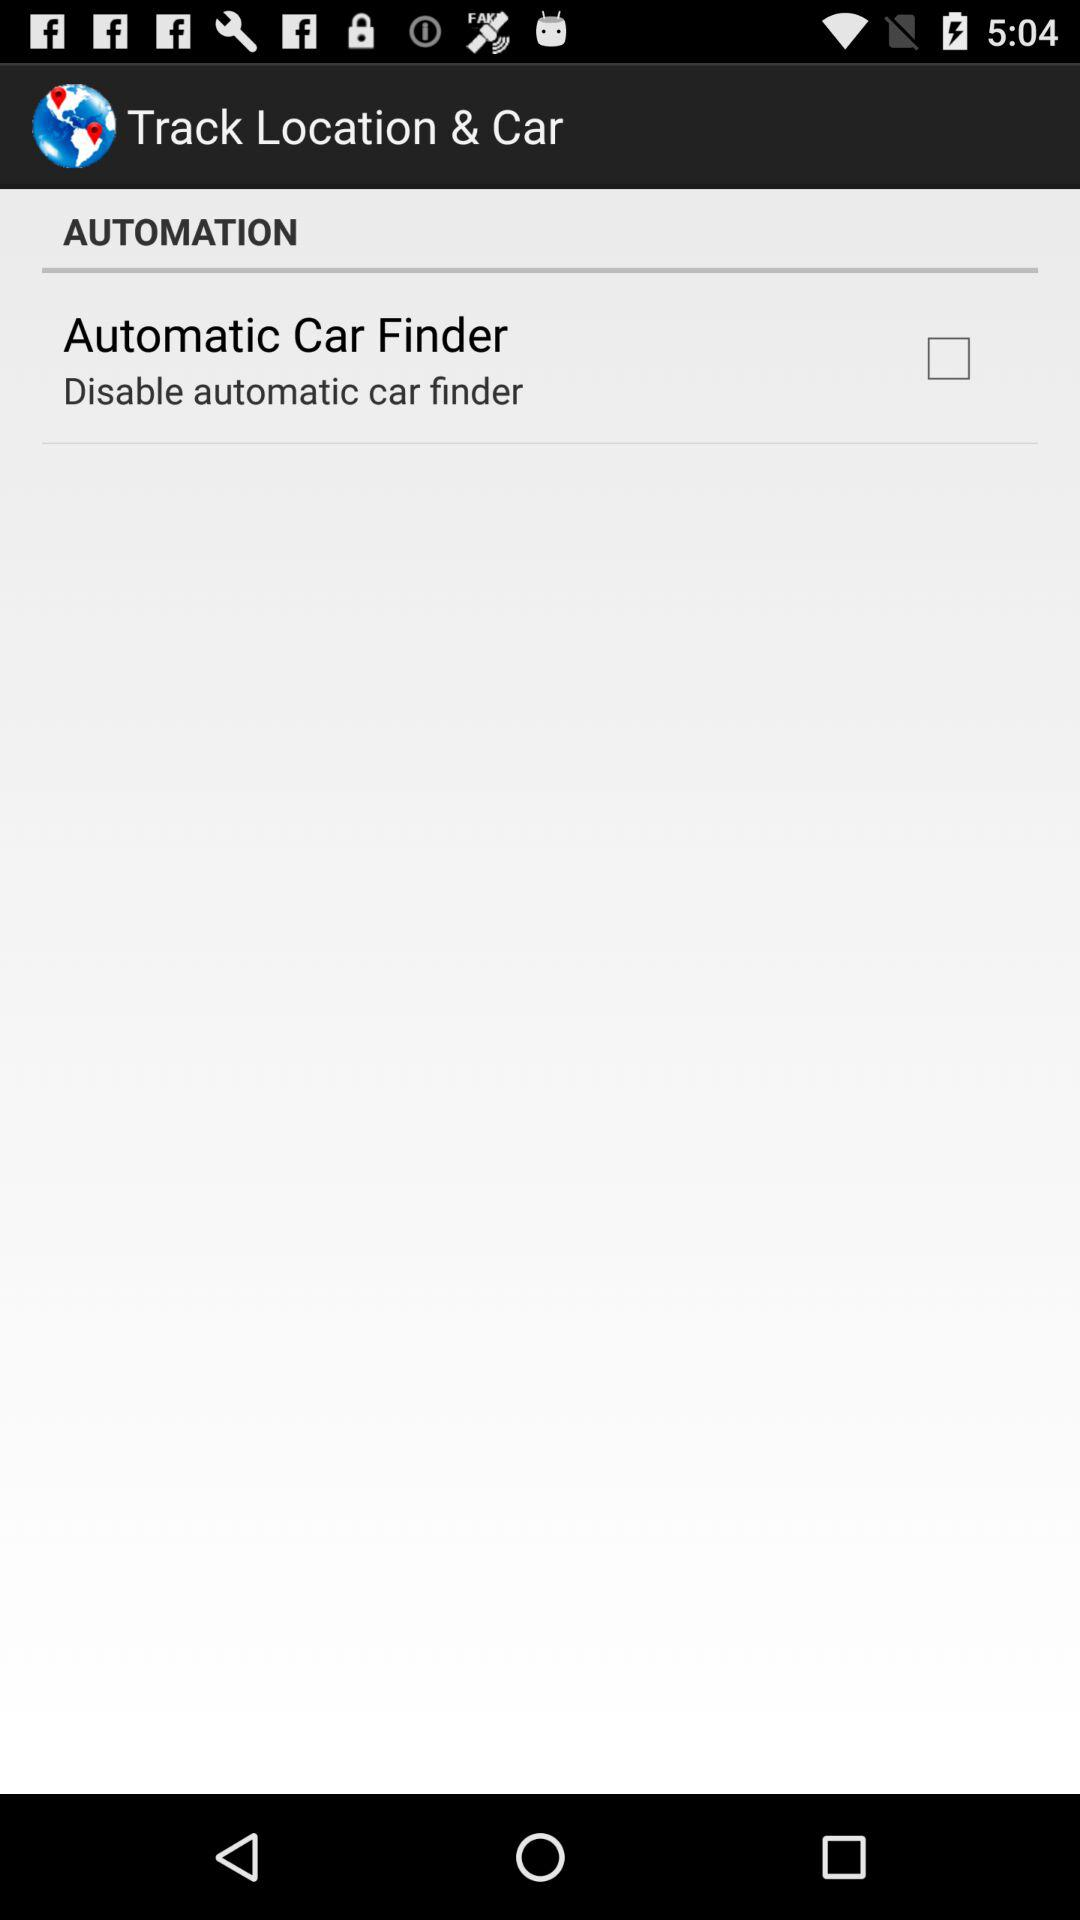What is the status of the automatic car finder? The status is off. 